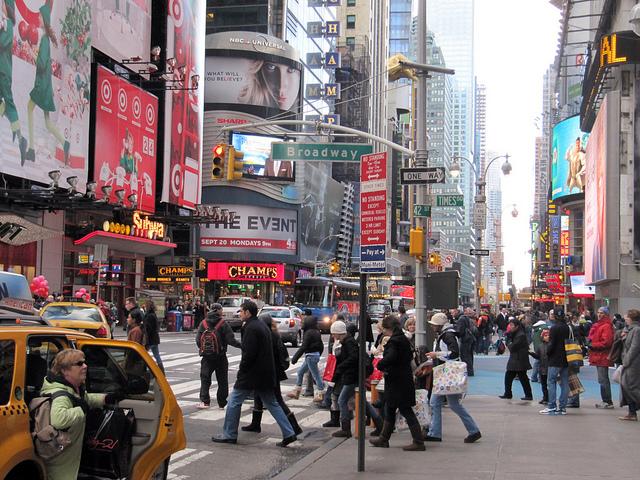Is this a scene in the United States of America?
Answer briefly. Yes. What is the purpose for all of the signs?
Give a very brief answer. Advertisement. What state is this scene in?
Concise answer only. New york. What is the name of the street on the sign?
Concise answer only. Broadway. How many people are in the foreground?
Quick response, please. 50. Is this in America?
Be succinct. Yes. How many photos are in this series?
Write a very short answer. 10. 